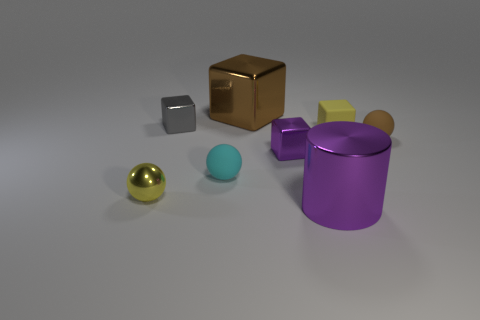Are there an equal number of cubes behind the tiny gray cube and brown metallic objects?
Your answer should be very brief. Yes. There is a metal block that is left of the brown metal cube; what size is it?
Offer a terse response. Small. How many gray rubber objects are the same shape as the yellow rubber object?
Keep it short and to the point. 0. The object that is to the left of the small cyan rubber ball and in front of the cyan thing is made of what material?
Offer a terse response. Metal. Are the cyan sphere and the brown sphere made of the same material?
Offer a very short reply. Yes. How many big purple metallic objects are there?
Provide a succinct answer. 1. There is a big thing in front of the matte ball that is behind the tiny shiny object that is to the right of the brown cube; what is its color?
Offer a very short reply. Purple. Is the color of the big cylinder the same as the shiny sphere?
Offer a terse response. No. What number of things are behind the cylinder and in front of the gray thing?
Provide a succinct answer. 5. What number of metal things are big brown cubes or brown cylinders?
Provide a succinct answer. 1. 